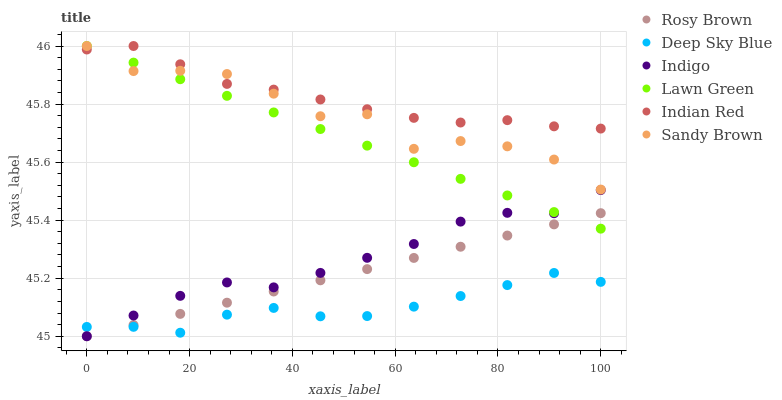Does Deep Sky Blue have the minimum area under the curve?
Answer yes or no. Yes. Does Indian Red have the maximum area under the curve?
Answer yes or no. Yes. Does Indigo have the minimum area under the curve?
Answer yes or no. No. Does Indigo have the maximum area under the curve?
Answer yes or no. No. Is Rosy Brown the smoothest?
Answer yes or no. Yes. Is Sandy Brown the roughest?
Answer yes or no. Yes. Is Indigo the smoothest?
Answer yes or no. No. Is Indigo the roughest?
Answer yes or no. No. Does Indigo have the lowest value?
Answer yes or no. Yes. Does Deep Sky Blue have the lowest value?
Answer yes or no. No. Does Sandy Brown have the highest value?
Answer yes or no. Yes. Does Indigo have the highest value?
Answer yes or no. No. Is Indigo less than Indian Red?
Answer yes or no. Yes. Is Sandy Brown greater than Deep Sky Blue?
Answer yes or no. Yes. Does Rosy Brown intersect Lawn Green?
Answer yes or no. Yes. Is Rosy Brown less than Lawn Green?
Answer yes or no. No. Is Rosy Brown greater than Lawn Green?
Answer yes or no. No. Does Indigo intersect Indian Red?
Answer yes or no. No. 